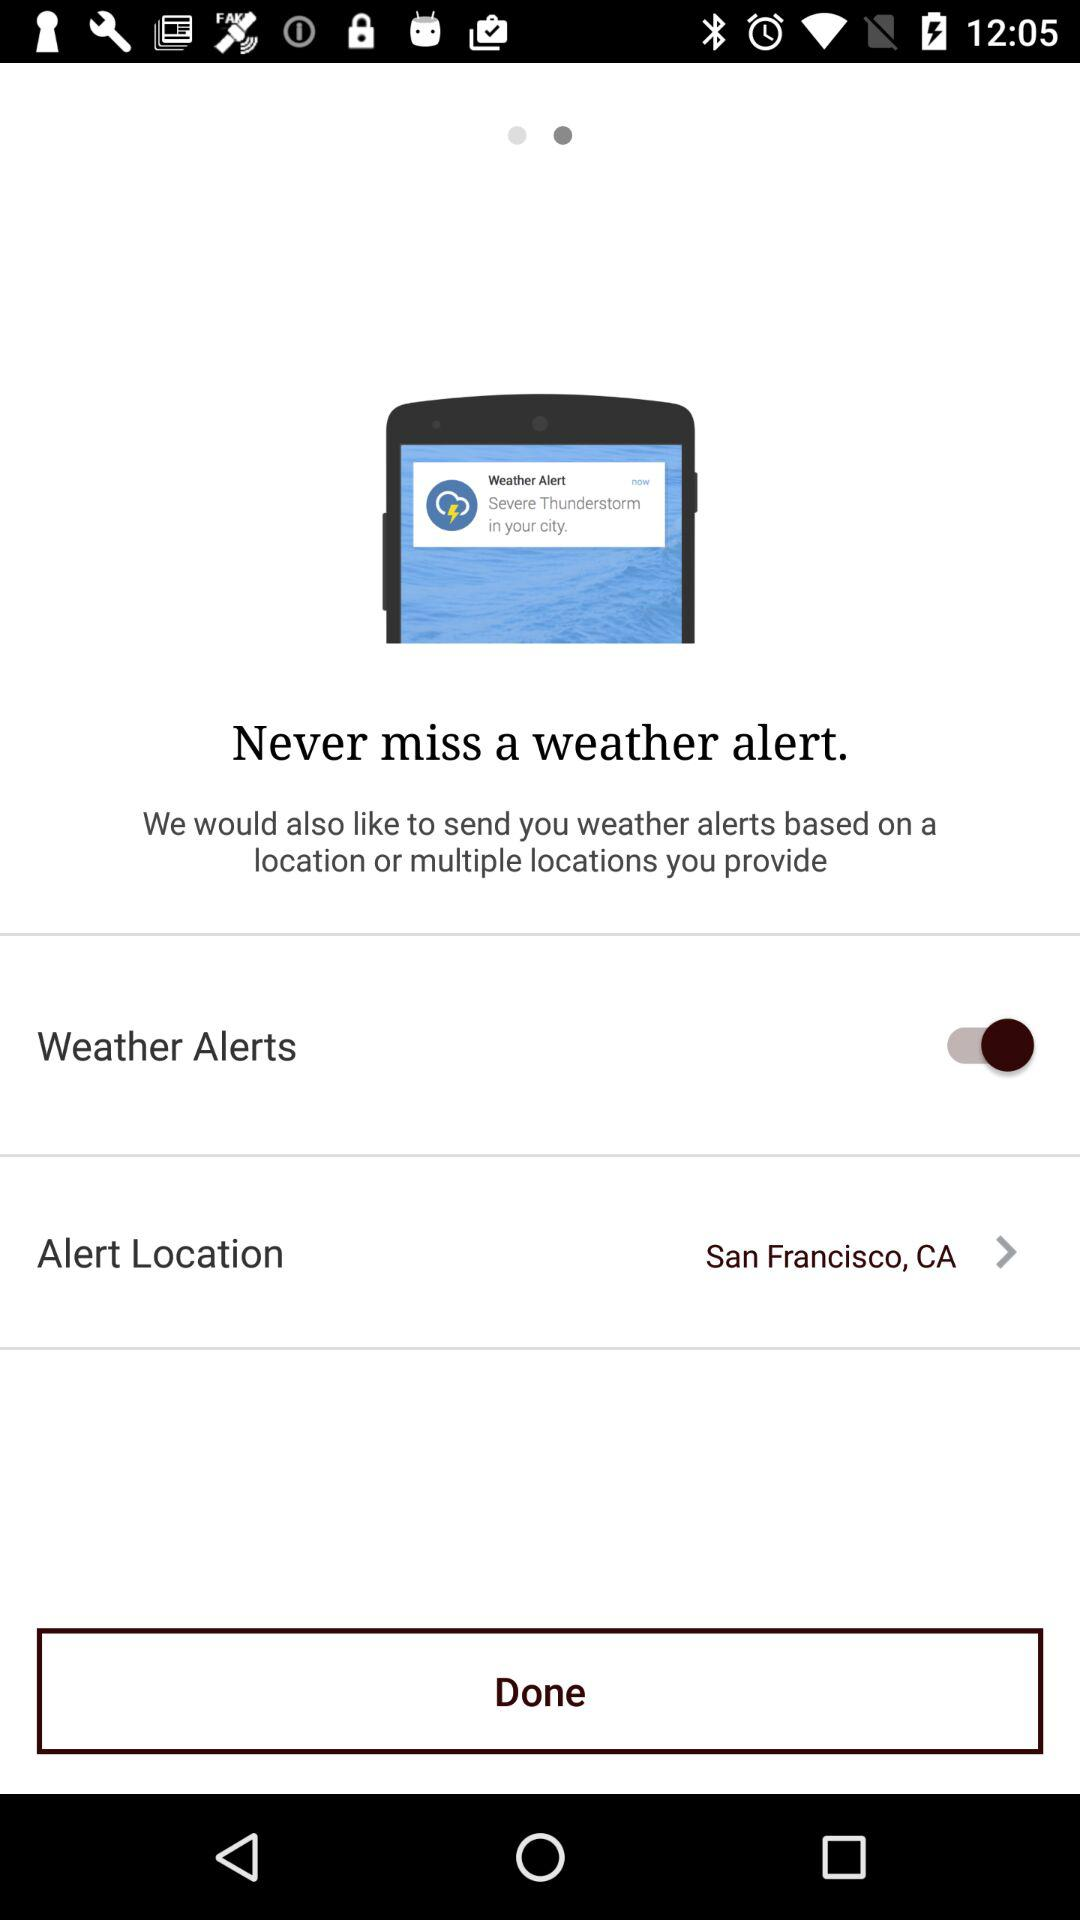What's the alert location? The alert location is San Francisco, CA. 